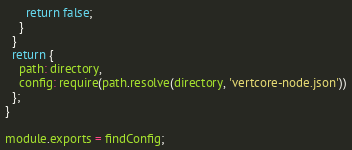<code> <loc_0><loc_0><loc_500><loc_500><_JavaScript_>      return false;
    }
  }
  return {
    path: directory,
    config: require(path.resolve(directory, 'vertcore-node.json'))
  };
}

module.exports = findConfig;
</code> 